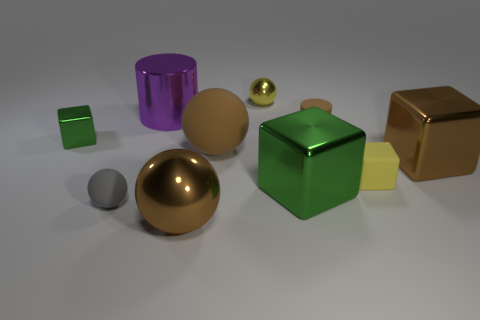Is the brown metal ball the same size as the yellow cube?
Offer a very short reply. No. Are the thing that is in front of the gray thing and the tiny brown object made of the same material?
Give a very brief answer. No. Are there any other things that have the same material as the tiny brown thing?
Make the answer very short. Yes. There is a metallic sphere behind the large ball that is in front of the yellow rubber thing; how many small balls are in front of it?
Offer a very short reply. 1. Do the matte thing that is on the right side of the tiny brown rubber cylinder and the purple metal thing have the same shape?
Keep it short and to the point. No. How many things are either green cubes or things on the left side of the brown metal sphere?
Provide a succinct answer. 4. Are there more brown matte cylinders that are to the right of the small matte sphere than tiny brown rubber cubes?
Offer a terse response. Yes. Is the number of small gray spheres to the left of the big brown metal sphere the same as the number of brown cubes to the left of the tiny brown thing?
Offer a terse response. No. Is there a brown matte cylinder that is right of the big brown matte ball that is in front of the metal cylinder?
Ensure brevity in your answer.  Yes. There is a yellow rubber object; what shape is it?
Give a very brief answer. Cube. 